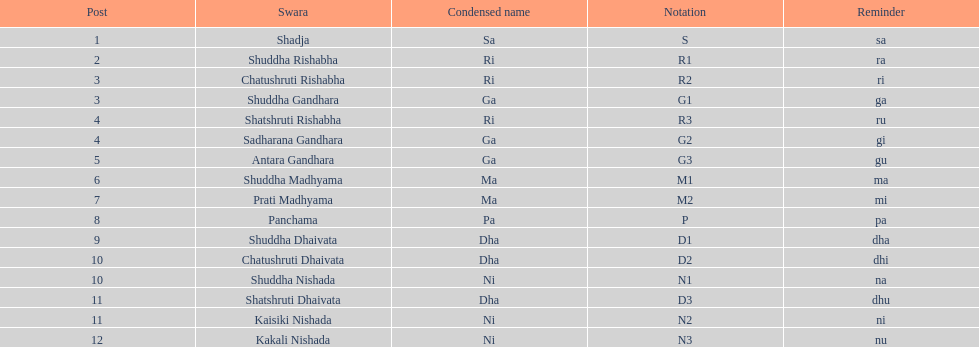List each pair of swaras that share the same position. Chatushruti Rishabha, Shuddha Gandhara, Shatshruti Rishabha, Sadharana Gandhara, Chatushruti Dhaivata, Shuddha Nishada, Shatshruti Dhaivata, Kaisiki Nishada. 